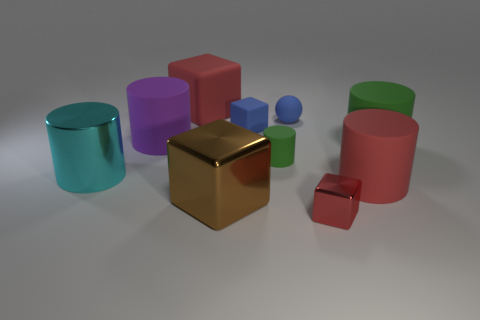Subtract all cyan cylinders. How many cylinders are left? 4 Subtract 1 blocks. How many blocks are left? 3 Subtract all cyan cylinders. How many cylinders are left? 4 Subtract all purple blocks. Subtract all brown cylinders. How many blocks are left? 4 Subtract all balls. How many objects are left? 9 Add 2 yellow spheres. How many yellow spheres exist? 2 Subtract 0 red spheres. How many objects are left? 10 Subtract all small blue cubes. Subtract all brown shiny objects. How many objects are left? 8 Add 4 big rubber objects. How many big rubber objects are left? 8 